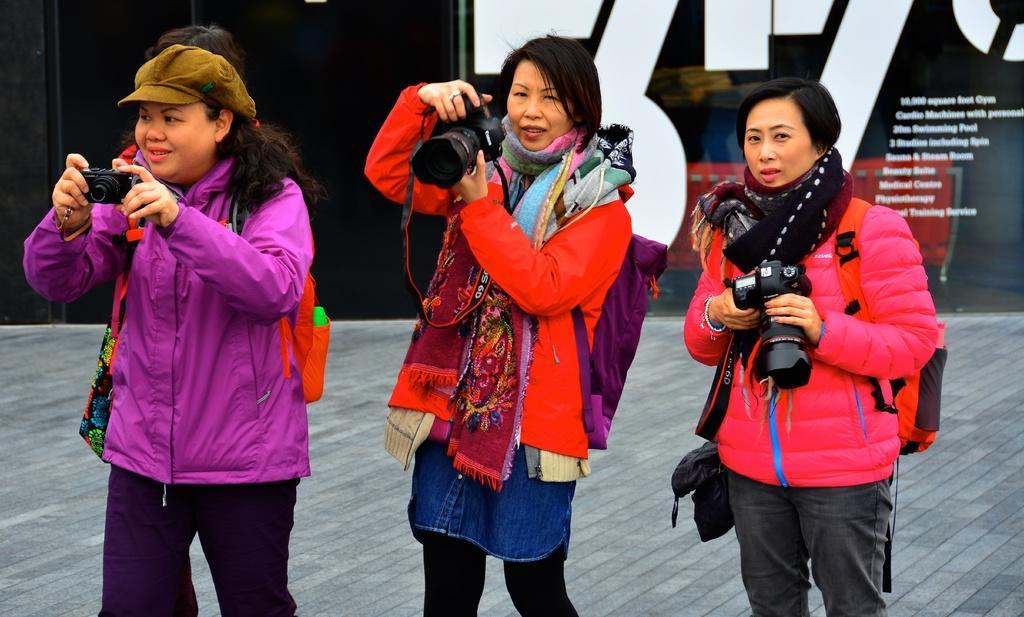Please provide a concise description of this image. In the image there are three ladies holding a camera. 